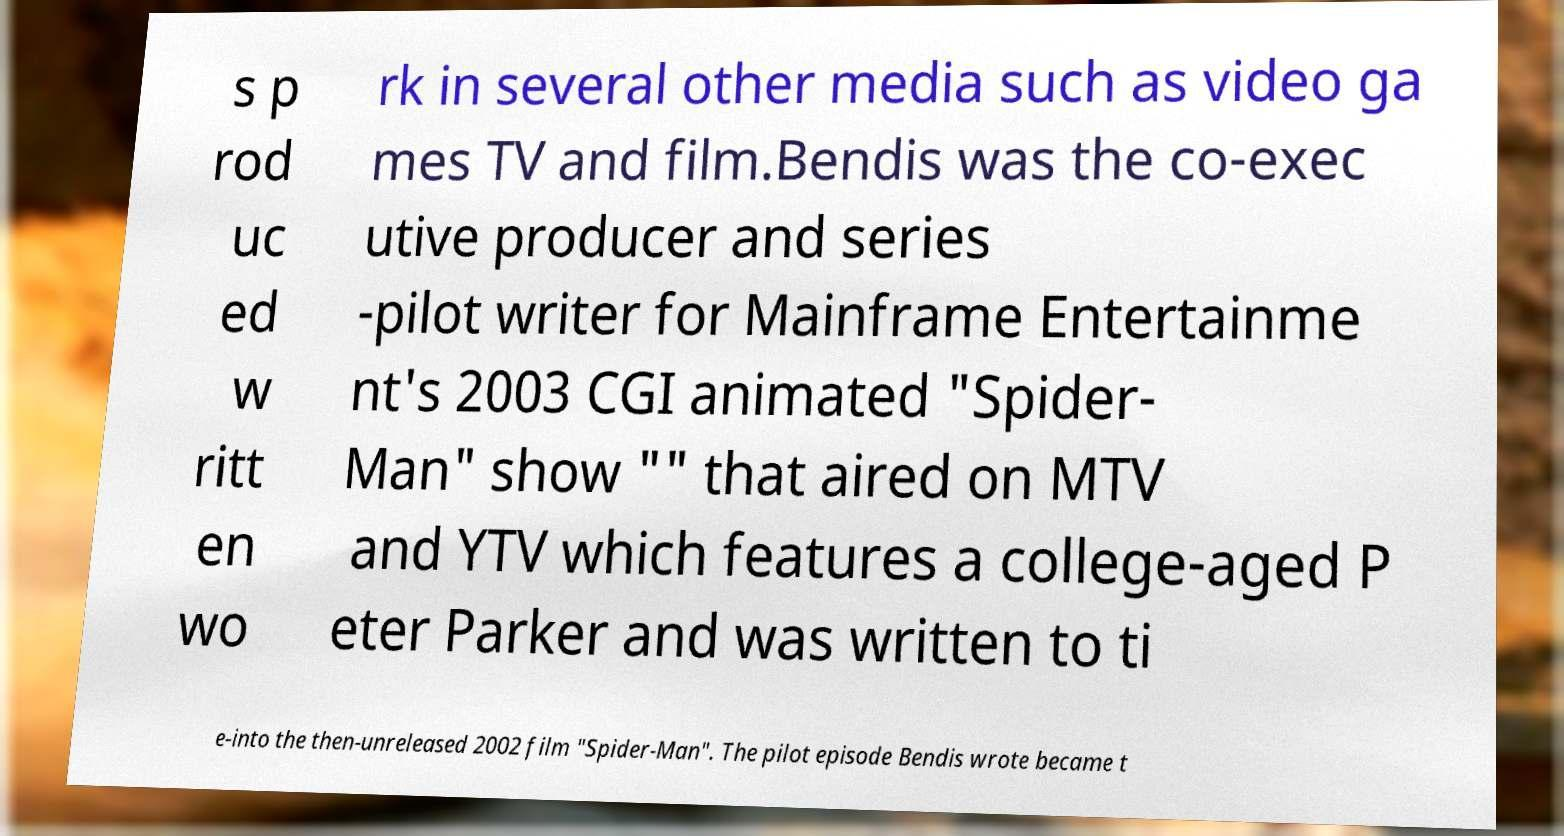I need the written content from this picture converted into text. Can you do that? s p rod uc ed w ritt en wo rk in several other media such as video ga mes TV and film.Bendis was the co-exec utive producer and series -pilot writer for Mainframe Entertainme nt's 2003 CGI animated "Spider- Man" show "" that aired on MTV and YTV which features a college-aged P eter Parker and was written to ti e-into the then-unreleased 2002 film "Spider-Man". The pilot episode Bendis wrote became t 